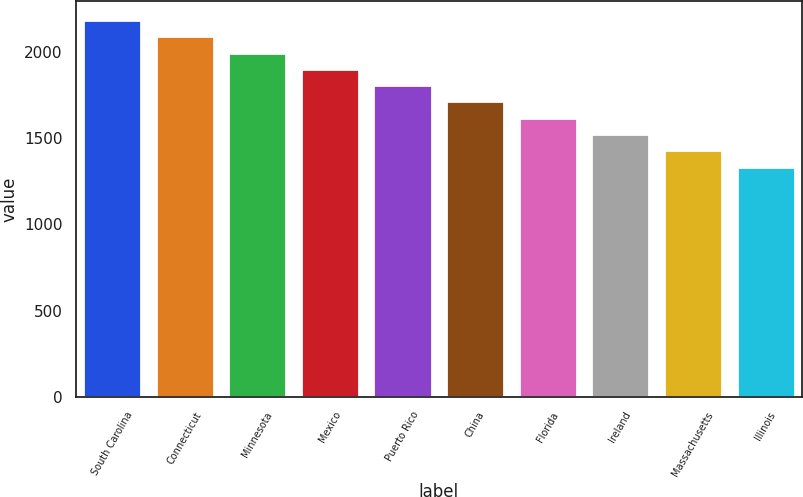Convert chart. <chart><loc_0><loc_0><loc_500><loc_500><bar_chart><fcel>South Carolina<fcel>Connecticut<fcel>Minnesota<fcel>Mexico<fcel>Puerto Rico<fcel>China<fcel>Florida<fcel>Ireland<fcel>Massachusetts<fcel>Illinois<nl><fcel>2186.6<fcel>2092<fcel>1997.4<fcel>1902.8<fcel>1808.2<fcel>1713.6<fcel>1619<fcel>1524.4<fcel>1429.8<fcel>1335.2<nl></chart> 